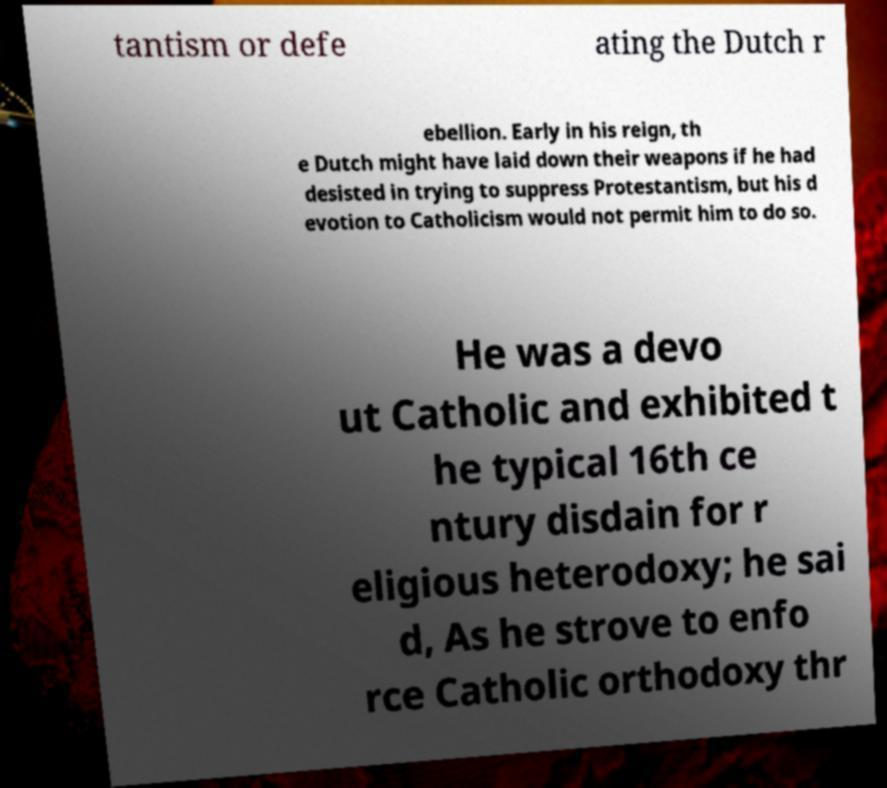Can you accurately transcribe the text from the provided image for me? tantism or defe ating the Dutch r ebellion. Early in his reign, th e Dutch might have laid down their weapons if he had desisted in trying to suppress Protestantism, but his d evotion to Catholicism would not permit him to do so. He was a devo ut Catholic and exhibited t he typical 16th ce ntury disdain for r eligious heterodoxy; he sai d, As he strove to enfo rce Catholic orthodoxy thr 